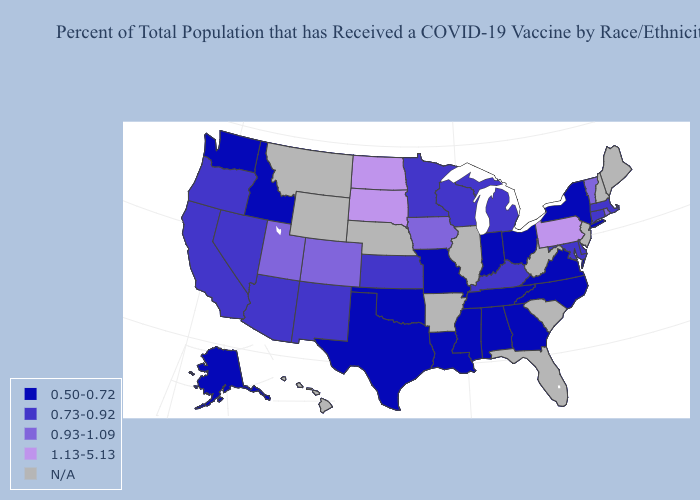Name the states that have a value in the range 0.50-0.72?
Short answer required. Alabama, Alaska, Georgia, Idaho, Indiana, Louisiana, Mississippi, Missouri, New York, North Carolina, Ohio, Oklahoma, Tennessee, Texas, Virginia, Washington. What is the lowest value in the South?
Keep it brief. 0.50-0.72. What is the highest value in states that border Tennessee?
Keep it brief. 0.73-0.92. Which states have the highest value in the USA?
Concise answer only. North Dakota, Pennsylvania, South Dakota. Name the states that have a value in the range 0.73-0.92?
Give a very brief answer. Arizona, California, Connecticut, Delaware, Kansas, Kentucky, Maryland, Massachusetts, Michigan, Minnesota, Nevada, New Mexico, Oregon, Wisconsin. Which states have the lowest value in the USA?
Keep it brief. Alabama, Alaska, Georgia, Idaho, Indiana, Louisiana, Mississippi, Missouri, New York, North Carolina, Ohio, Oklahoma, Tennessee, Texas, Virginia, Washington. Does Alaska have the highest value in the West?
Be succinct. No. What is the value of Kentucky?
Keep it brief. 0.73-0.92. Name the states that have a value in the range N/A?
Concise answer only. Arkansas, Florida, Hawaii, Illinois, Maine, Montana, Nebraska, New Hampshire, New Jersey, South Carolina, West Virginia, Wyoming. Does New Mexico have the lowest value in the USA?
Short answer required. No. What is the lowest value in the USA?
Concise answer only. 0.50-0.72. What is the highest value in the USA?
Keep it brief. 1.13-5.13. Name the states that have a value in the range 0.73-0.92?
Give a very brief answer. Arizona, California, Connecticut, Delaware, Kansas, Kentucky, Maryland, Massachusetts, Michigan, Minnesota, Nevada, New Mexico, Oregon, Wisconsin. 